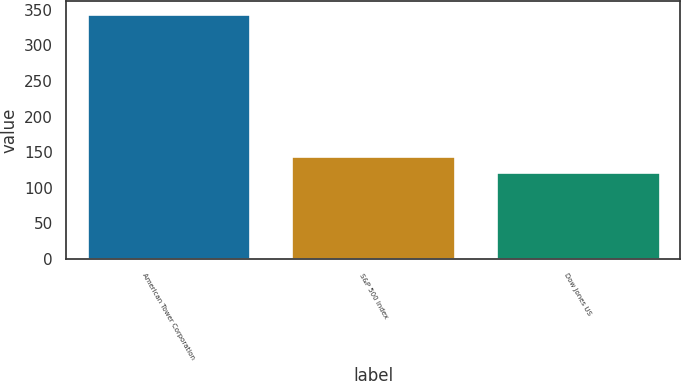Convert chart. <chart><loc_0><loc_0><loc_500><loc_500><bar_chart><fcel>American Tower Corporation<fcel>S&P 500 Index<fcel>Dow Jones US<nl><fcel>344.55<fcel>144.79<fcel>122.59<nl></chart> 